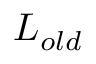Convert formula to latex. <formula><loc_0><loc_0><loc_500><loc_500>L _ { o l d }</formula> 